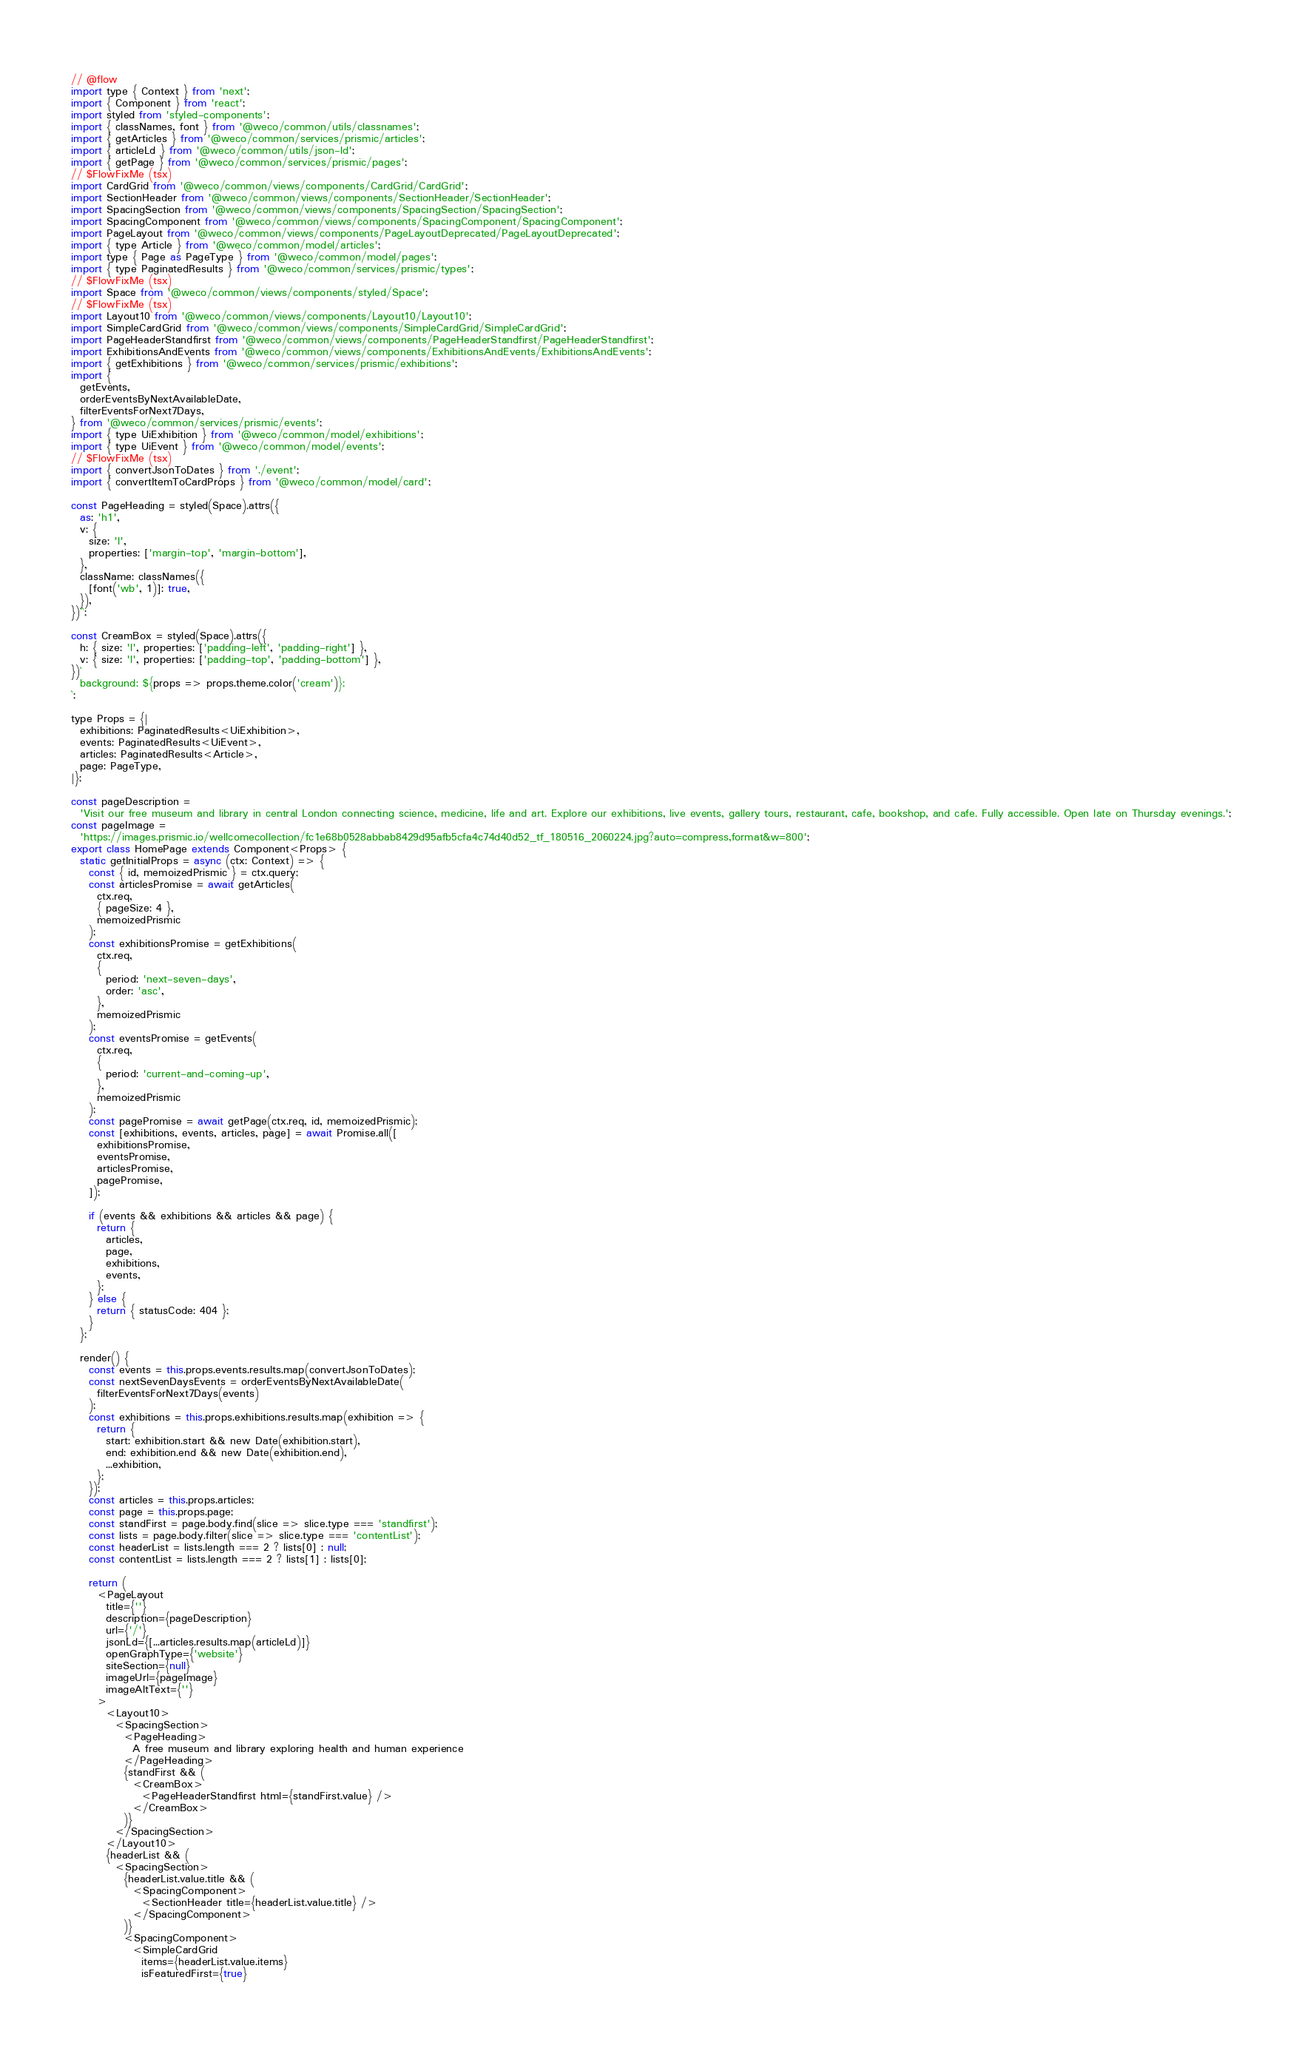<code> <loc_0><loc_0><loc_500><loc_500><_JavaScript_>// @flow
import type { Context } from 'next';
import { Component } from 'react';
import styled from 'styled-components';
import { classNames, font } from '@weco/common/utils/classnames';
import { getArticles } from '@weco/common/services/prismic/articles';
import { articleLd } from '@weco/common/utils/json-ld';
import { getPage } from '@weco/common/services/prismic/pages';
// $FlowFixMe (tsx)
import CardGrid from '@weco/common/views/components/CardGrid/CardGrid';
import SectionHeader from '@weco/common/views/components/SectionHeader/SectionHeader';
import SpacingSection from '@weco/common/views/components/SpacingSection/SpacingSection';
import SpacingComponent from '@weco/common/views/components/SpacingComponent/SpacingComponent';
import PageLayout from '@weco/common/views/components/PageLayoutDeprecated/PageLayoutDeprecated';
import { type Article } from '@weco/common/model/articles';
import type { Page as PageType } from '@weco/common/model/pages';
import { type PaginatedResults } from '@weco/common/services/prismic/types';
// $FlowFixMe (tsx)
import Space from '@weco/common/views/components/styled/Space';
// $FlowFixMe (tsx)
import Layout10 from '@weco/common/views/components/Layout10/Layout10';
import SimpleCardGrid from '@weco/common/views/components/SimpleCardGrid/SimpleCardGrid';
import PageHeaderStandfirst from '@weco/common/views/components/PageHeaderStandfirst/PageHeaderStandfirst';
import ExhibitionsAndEvents from '@weco/common/views/components/ExhibitionsAndEvents/ExhibitionsAndEvents';
import { getExhibitions } from '@weco/common/services/prismic/exhibitions';
import {
  getEvents,
  orderEventsByNextAvailableDate,
  filterEventsForNext7Days,
} from '@weco/common/services/prismic/events';
import { type UiExhibition } from '@weco/common/model/exhibitions';
import { type UiEvent } from '@weco/common/model/events';
// $FlowFixMe (tsx)
import { convertJsonToDates } from './event';
import { convertItemToCardProps } from '@weco/common/model/card';

const PageHeading = styled(Space).attrs({
  as: 'h1',
  v: {
    size: 'l',
    properties: ['margin-top', 'margin-bottom'],
  },
  className: classNames({
    [font('wb', 1)]: true,
  }),
})``;

const CreamBox = styled(Space).attrs({
  h: { size: 'l', properties: ['padding-left', 'padding-right'] },
  v: { size: 'l', properties: ['padding-top', 'padding-bottom'] },
})`
  background: ${props => props.theme.color('cream')};
`;

type Props = {|
  exhibitions: PaginatedResults<UiExhibition>,
  events: PaginatedResults<UiEvent>,
  articles: PaginatedResults<Article>,
  page: PageType,
|};

const pageDescription =
  'Visit our free museum and library in central London connecting science, medicine, life and art. Explore our exhibitions, live events, gallery tours, restaurant, cafe, bookshop, and cafe. Fully accessible. Open late on Thursday evenings.';
const pageImage =
  'https://images.prismic.io/wellcomecollection/fc1e68b0528abbab8429d95afb5cfa4c74d40d52_tf_180516_2060224.jpg?auto=compress,format&w=800';
export class HomePage extends Component<Props> {
  static getInitialProps = async (ctx: Context) => {
    const { id, memoizedPrismic } = ctx.query;
    const articlesPromise = await getArticles(
      ctx.req,
      { pageSize: 4 },
      memoizedPrismic
    );
    const exhibitionsPromise = getExhibitions(
      ctx.req,
      {
        period: 'next-seven-days',
        order: 'asc',
      },
      memoizedPrismic
    );
    const eventsPromise = getEvents(
      ctx.req,
      {
        period: 'current-and-coming-up',
      },
      memoizedPrismic
    );
    const pagePromise = await getPage(ctx.req, id, memoizedPrismic);
    const [exhibitions, events, articles, page] = await Promise.all([
      exhibitionsPromise,
      eventsPromise,
      articlesPromise,
      pagePromise,
    ]);

    if (events && exhibitions && articles && page) {
      return {
        articles,
        page,
        exhibitions,
        events,
      };
    } else {
      return { statusCode: 404 };
    }
  };

  render() {
    const events = this.props.events.results.map(convertJsonToDates);
    const nextSevenDaysEvents = orderEventsByNextAvailableDate(
      filterEventsForNext7Days(events)
    );
    const exhibitions = this.props.exhibitions.results.map(exhibition => {
      return {
        start: exhibition.start && new Date(exhibition.start),
        end: exhibition.end && new Date(exhibition.end),
        ...exhibition,
      };
    });
    const articles = this.props.articles;
    const page = this.props.page;
    const standFirst = page.body.find(slice => slice.type === 'standfirst');
    const lists = page.body.filter(slice => slice.type === 'contentList');
    const headerList = lists.length === 2 ? lists[0] : null;
    const contentList = lists.length === 2 ? lists[1] : lists[0];

    return (
      <PageLayout
        title={''}
        description={pageDescription}
        url={'/'}
        jsonLd={[...articles.results.map(articleLd)]}
        openGraphType={'website'}
        siteSection={null}
        imageUrl={pageImage}
        imageAltText={''}
      >
        <Layout10>
          <SpacingSection>
            <PageHeading>
              A free museum and library exploring health and human experience
            </PageHeading>
            {standFirst && (
              <CreamBox>
                <PageHeaderStandfirst html={standFirst.value} />
              </CreamBox>
            )}
          </SpacingSection>
        </Layout10>
        {headerList && (
          <SpacingSection>
            {headerList.value.title && (
              <SpacingComponent>
                <SectionHeader title={headerList.value.title} />
              </SpacingComponent>
            )}
            <SpacingComponent>
              <SimpleCardGrid
                items={headerList.value.items}
                isFeaturedFirst={true}</code> 